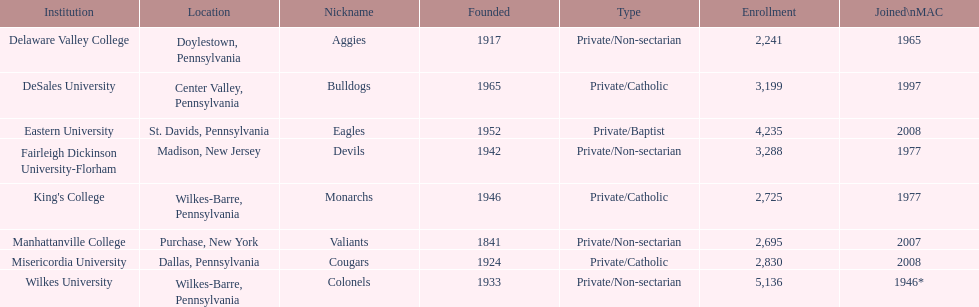What is the number of students enrolled in private/catholic schools? 8,754. 